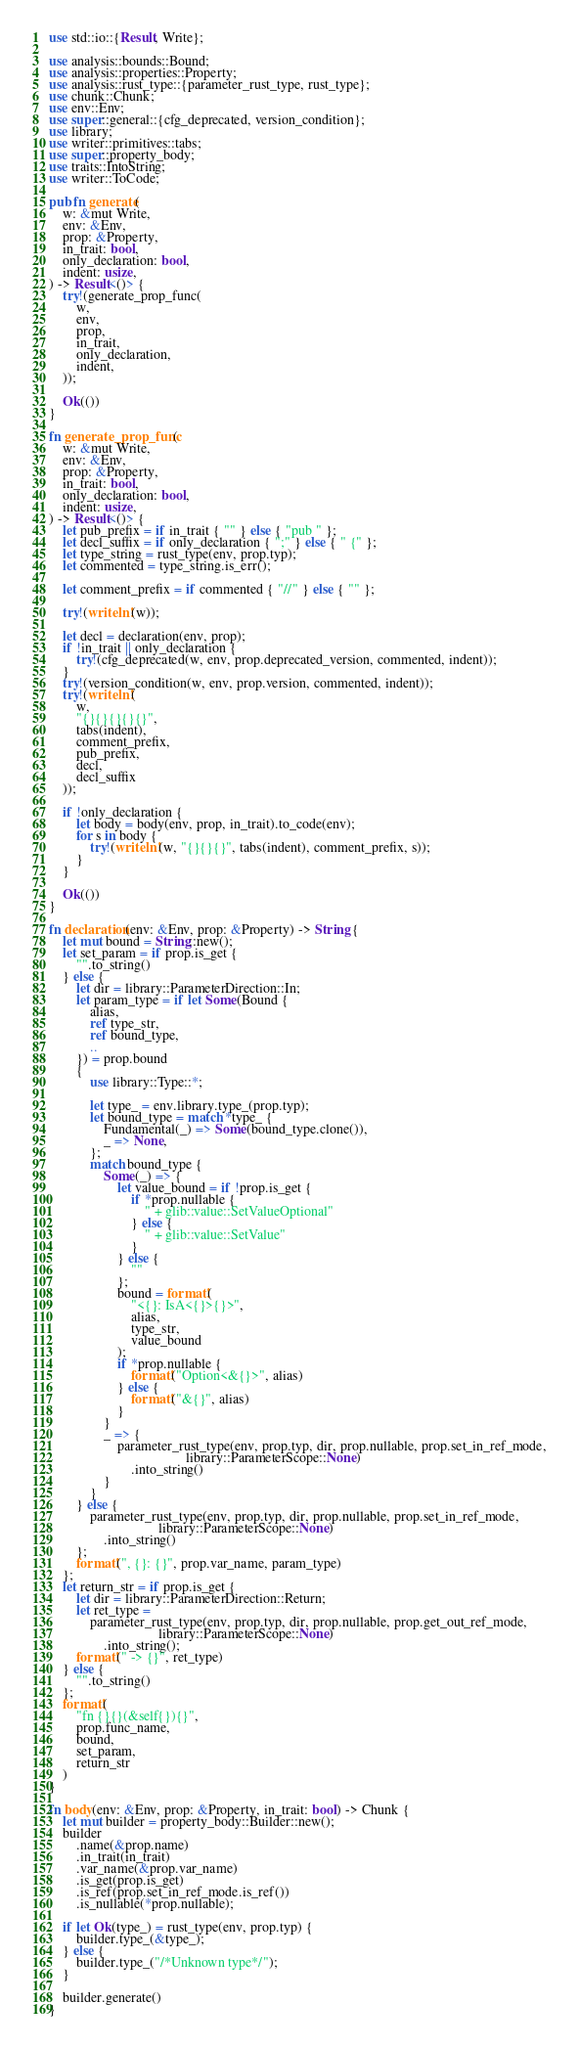<code> <loc_0><loc_0><loc_500><loc_500><_Rust_>use std::io::{Result, Write};

use analysis::bounds::Bound;
use analysis::properties::Property;
use analysis::rust_type::{parameter_rust_type, rust_type};
use chunk::Chunk;
use env::Env;
use super::general::{cfg_deprecated, version_condition};
use library;
use writer::primitives::tabs;
use super::property_body;
use traits::IntoString;
use writer::ToCode;

pub fn generate(
    w: &mut Write,
    env: &Env,
    prop: &Property,
    in_trait: bool,
    only_declaration: bool,
    indent: usize,
) -> Result<()> {
    try!(generate_prop_func(
        w,
        env,
        prop,
        in_trait,
        only_declaration,
        indent,
    ));

    Ok(())
}

fn generate_prop_func(
    w: &mut Write,
    env: &Env,
    prop: &Property,
    in_trait: bool,
    only_declaration: bool,
    indent: usize,
) -> Result<()> {
    let pub_prefix = if in_trait { "" } else { "pub " };
    let decl_suffix = if only_declaration { ";" } else { " {" };
    let type_string = rust_type(env, prop.typ);
    let commented = type_string.is_err();

    let comment_prefix = if commented { "//" } else { "" };

    try!(writeln!(w));

    let decl = declaration(env, prop);
    if !in_trait || only_declaration {
        try!(cfg_deprecated(w, env, prop.deprecated_version, commented, indent));
    }
    try!(version_condition(w, env, prop.version, commented, indent));
    try!(writeln!(
        w,
        "{}{}{}{}{}",
        tabs(indent),
        comment_prefix,
        pub_prefix,
        decl,
        decl_suffix
    ));

    if !only_declaration {
        let body = body(env, prop, in_trait).to_code(env);
        for s in body {
            try!(writeln!(w, "{}{}{}", tabs(indent), comment_prefix, s));
        }
    }

    Ok(())
}

fn declaration(env: &Env, prop: &Property) -> String {
    let mut bound = String::new();
    let set_param = if prop.is_get {
        "".to_string()
    } else {
        let dir = library::ParameterDirection::In;
        let param_type = if let Some(Bound {
            alias,
            ref type_str,
            ref bound_type,
            ..
        }) = prop.bound
        {
            use library::Type::*;

            let type_ = env.library.type_(prop.typ);
            let bound_type = match *type_ {
                Fundamental(_) => Some(bound_type.clone()),
                _ => None,
            };
            match bound_type {
                Some(_) => {
                    let value_bound = if !prop.is_get {
                        if *prop.nullable {
                            " + glib::value::SetValueOptional"
                        } else {
                            " + glib::value::SetValue"
                        }
                    } else {
                        ""
                    };
                    bound = format!(
                        "<{}: IsA<{}>{}>",
                        alias,
                        type_str,
                        value_bound
                    );
                    if *prop.nullable {
                        format!("Option<&{}>", alias)
                    } else {
                        format!("&{}", alias)
                    }
                }
                _ => {
                    parameter_rust_type(env, prop.typ, dir, prop.nullable, prop.set_in_ref_mode,
                                        library::ParameterScope::None)
                        .into_string()
                }
            }
        } else {
            parameter_rust_type(env, prop.typ, dir, prop.nullable, prop.set_in_ref_mode,
                                library::ParameterScope::None)
                .into_string()
        };
        format!(", {}: {}", prop.var_name, param_type)
    };
    let return_str = if prop.is_get {
        let dir = library::ParameterDirection::Return;
        let ret_type =
            parameter_rust_type(env, prop.typ, dir, prop.nullable, prop.get_out_ref_mode,
                                library::ParameterScope::None)
                .into_string();
        format!(" -> {}", ret_type)
    } else {
        "".to_string()
    };
    format!(
        "fn {}{}(&self{}){}",
        prop.func_name,
        bound,
        set_param,
        return_str
    )
}

fn body(env: &Env, prop: &Property, in_trait: bool) -> Chunk {
    let mut builder = property_body::Builder::new();
    builder
        .name(&prop.name)
        .in_trait(in_trait)
        .var_name(&prop.var_name)
        .is_get(prop.is_get)
        .is_ref(prop.set_in_ref_mode.is_ref())
        .is_nullable(*prop.nullable);

    if let Ok(type_) = rust_type(env, prop.typ) {
        builder.type_(&type_);
    } else {
        builder.type_("/*Unknown type*/");
    }

    builder.generate()
}
</code> 